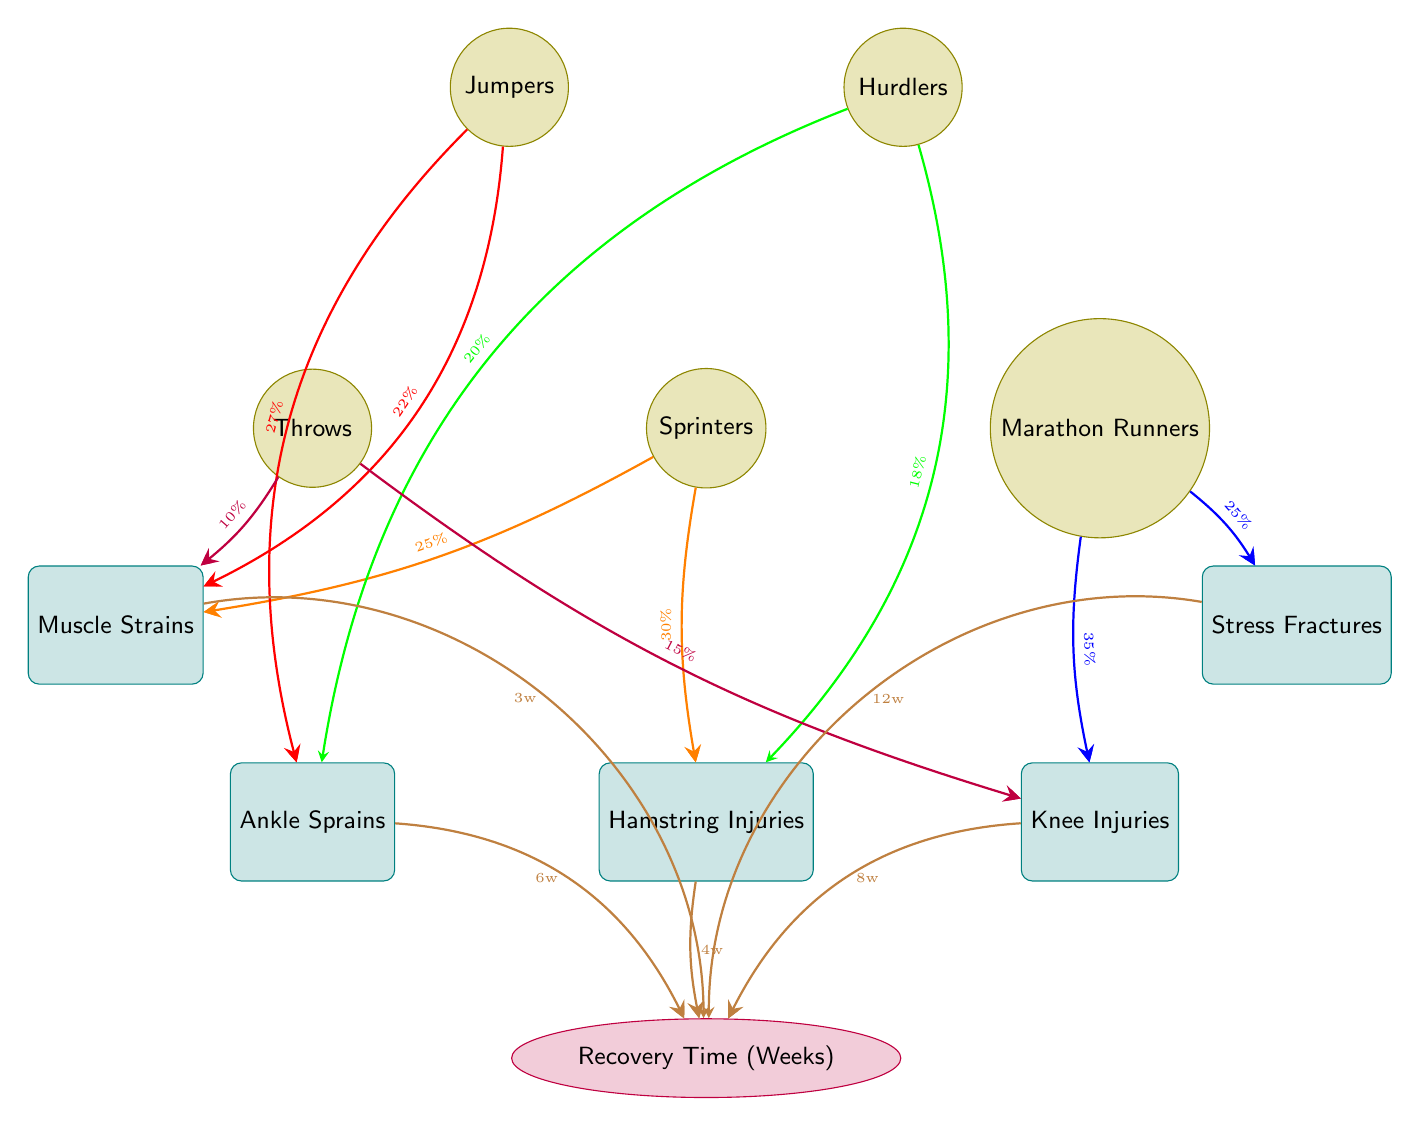What percentage of sprinters suffer from hamstring injuries? The diagram shows a connection from "Sprinters" to "Hamstring Injuries" labeled with 30%. This is the percentage of sprinters affected by this type of injury.
Answer: 30% How many weeks is the recovery time for knee injuries? The connection from "Knee Injuries" to "Recovery Time (Weeks)" indicates a recovery time of 8 weeks. This is stated directly in the diagram.
Answer: 8 weeks Which group is associated with the highest incidence of ankle sprains? The connections for "Ankle Sprains" come from both "Hurdlers" and "Jumpers", with 20% from Hurdlers and 27% from Jumpers. Jumpers have the higher percentage, indicating they have the highest incidence of this injury.
Answer: Jumpers What is the recovery time for stress fractures? The diagram clearly connects "Stress Fractures" to "Recovery Time (Weeks)" with a label of 12 weeks. This specifies the recovery duration expected for this injury.
Answer: 12 weeks Which injury has the shortest recovery time? The recovery times connected from various injuries show: hamstring injuries (4 weeks), knee injuries (8 weeks), ankle sprains (6 weeks), stress fractures (12 weeks), and muscle strains (3 weeks). Among these, muscle strains have the shortest at 3 weeks.
Answer: 3 weeks What is the total percentage of injuries associated with marathon runners? From the diagram, marathon runners are linked to knee injuries (35%) and stress fractures (25%). Adding these together gives a total of 60%.
Answer: 60% How many different types of injuries are shown in the diagram? The diagram presents five distinct injuries: hamstring injuries, knee injuries, ankle sprains, stress fractures, and muscle strains. Counting these, we find that there are five types depicted.
Answer: 5 What is the rate of muscle strains for sprinters? The connection from "Sprinters" to "Muscle Strains" indicates a percentage of 25%. This demonstrates the incidence rate of this injury among sprinters.
Answer: 25% Which sport has the lowest percentage of injuries depicted in the diagram? The percentages for different sports are: sprinters (55%), marathon runners (60%), hurdlers (38%), jumpers (49%), and throws (25%). The "Throws" have the lowest at 25%.
Answer: Throws 